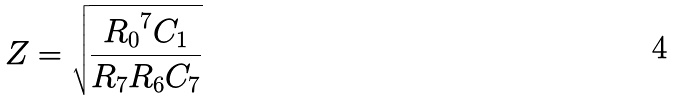Convert formula to latex. <formula><loc_0><loc_0><loc_500><loc_500>Z = \sqrt { \frac { { R _ { 0 } } ^ { 7 } C _ { 1 } } { R _ { 7 } R _ { 6 } C _ { 7 } } }</formula> 